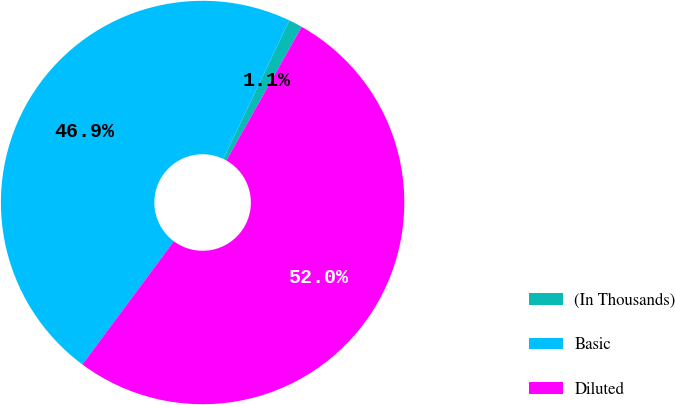Convert chart to OTSL. <chart><loc_0><loc_0><loc_500><loc_500><pie_chart><fcel>(In Thousands)<fcel>Basic<fcel>Diluted<nl><fcel>1.1%<fcel>46.91%<fcel>51.99%<nl></chart> 